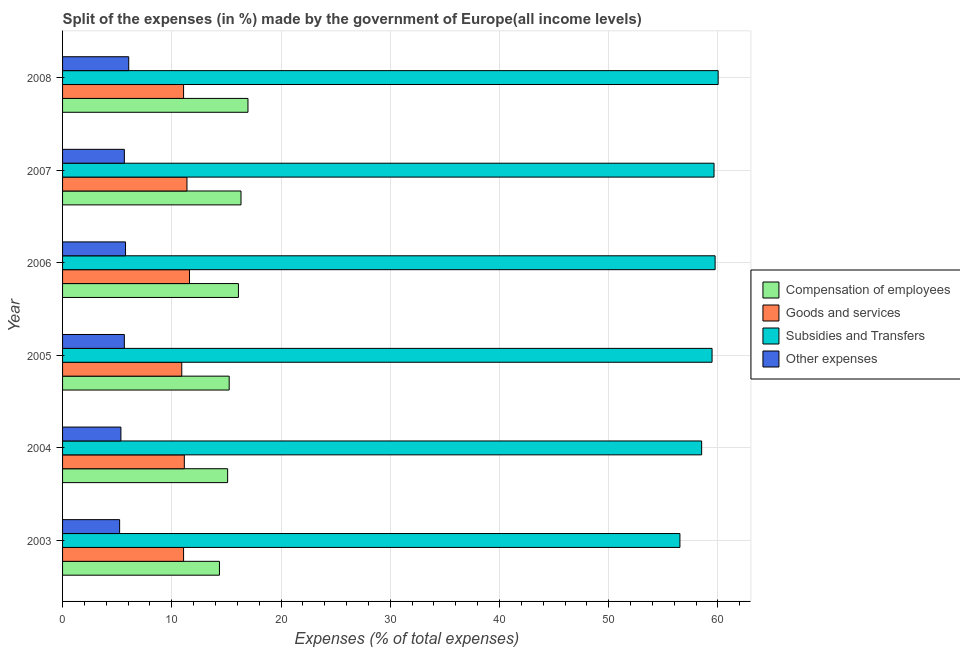How many groups of bars are there?
Keep it short and to the point. 6. How many bars are there on the 4th tick from the top?
Keep it short and to the point. 4. How many bars are there on the 6th tick from the bottom?
Ensure brevity in your answer.  4. In how many cases, is the number of bars for a given year not equal to the number of legend labels?
Make the answer very short. 0. What is the percentage of amount spent on goods and services in 2005?
Ensure brevity in your answer.  10.91. Across all years, what is the maximum percentage of amount spent on other expenses?
Your answer should be compact. 6.06. Across all years, what is the minimum percentage of amount spent on goods and services?
Provide a short and direct response. 10.91. In which year was the percentage of amount spent on goods and services minimum?
Your response must be concise. 2005. What is the total percentage of amount spent on compensation of employees in the graph?
Offer a terse response. 94.13. What is the difference between the percentage of amount spent on compensation of employees in 2007 and that in 2008?
Your response must be concise. -0.64. What is the difference between the percentage of amount spent on compensation of employees in 2007 and the percentage of amount spent on subsidies in 2008?
Provide a succinct answer. -43.68. What is the average percentage of amount spent on other expenses per year?
Give a very brief answer. 5.62. In the year 2007, what is the difference between the percentage of amount spent on compensation of employees and percentage of amount spent on other expenses?
Your answer should be compact. 10.68. What is the ratio of the percentage of amount spent on other expenses in 2003 to that in 2005?
Your response must be concise. 0.92. Is the difference between the percentage of amount spent on goods and services in 2005 and 2007 greater than the difference between the percentage of amount spent on compensation of employees in 2005 and 2007?
Offer a very short reply. Yes. What is the difference between the highest and the second highest percentage of amount spent on subsidies?
Your response must be concise. 0.28. What is the difference between the highest and the lowest percentage of amount spent on subsidies?
Offer a terse response. 3.5. In how many years, is the percentage of amount spent on other expenses greater than the average percentage of amount spent on other expenses taken over all years?
Your response must be concise. 4. Is the sum of the percentage of amount spent on compensation of employees in 2006 and 2007 greater than the maximum percentage of amount spent on subsidies across all years?
Provide a succinct answer. No. What does the 1st bar from the top in 2007 represents?
Your response must be concise. Other expenses. What does the 1st bar from the bottom in 2008 represents?
Your answer should be very brief. Compensation of employees. Is it the case that in every year, the sum of the percentage of amount spent on compensation of employees and percentage of amount spent on goods and services is greater than the percentage of amount spent on subsidies?
Your answer should be very brief. No. How many years are there in the graph?
Your response must be concise. 6. Where does the legend appear in the graph?
Offer a terse response. Center right. What is the title of the graph?
Keep it short and to the point. Split of the expenses (in %) made by the government of Europe(all income levels). What is the label or title of the X-axis?
Provide a succinct answer. Expenses (% of total expenses). What is the label or title of the Y-axis?
Provide a succinct answer. Year. What is the Expenses (% of total expenses) of Compensation of employees in 2003?
Give a very brief answer. 14.36. What is the Expenses (% of total expenses) in Goods and services in 2003?
Your answer should be very brief. 11.08. What is the Expenses (% of total expenses) of Subsidies and Transfers in 2003?
Your answer should be compact. 56.51. What is the Expenses (% of total expenses) in Other expenses in 2003?
Provide a succinct answer. 5.22. What is the Expenses (% of total expenses) in Compensation of employees in 2004?
Make the answer very short. 15.11. What is the Expenses (% of total expenses) of Goods and services in 2004?
Provide a short and direct response. 11.15. What is the Expenses (% of total expenses) in Subsidies and Transfers in 2004?
Keep it short and to the point. 58.5. What is the Expenses (% of total expenses) in Other expenses in 2004?
Your answer should be very brief. 5.34. What is the Expenses (% of total expenses) of Compensation of employees in 2005?
Make the answer very short. 15.25. What is the Expenses (% of total expenses) of Goods and services in 2005?
Provide a short and direct response. 10.91. What is the Expenses (% of total expenses) of Subsidies and Transfers in 2005?
Your response must be concise. 59.46. What is the Expenses (% of total expenses) in Other expenses in 2005?
Make the answer very short. 5.65. What is the Expenses (% of total expenses) of Compensation of employees in 2006?
Offer a terse response. 16.1. What is the Expenses (% of total expenses) of Goods and services in 2006?
Make the answer very short. 11.62. What is the Expenses (% of total expenses) of Subsidies and Transfers in 2006?
Ensure brevity in your answer.  59.74. What is the Expenses (% of total expenses) of Other expenses in 2006?
Offer a terse response. 5.76. What is the Expenses (% of total expenses) in Compensation of employees in 2007?
Make the answer very short. 16.34. What is the Expenses (% of total expenses) in Goods and services in 2007?
Give a very brief answer. 11.39. What is the Expenses (% of total expenses) in Subsidies and Transfers in 2007?
Make the answer very short. 59.64. What is the Expenses (% of total expenses) in Other expenses in 2007?
Provide a succinct answer. 5.66. What is the Expenses (% of total expenses) in Compensation of employees in 2008?
Keep it short and to the point. 16.97. What is the Expenses (% of total expenses) of Goods and services in 2008?
Offer a very short reply. 11.08. What is the Expenses (% of total expenses) in Subsidies and Transfers in 2008?
Provide a succinct answer. 60.01. What is the Expenses (% of total expenses) in Other expenses in 2008?
Offer a very short reply. 6.06. Across all years, what is the maximum Expenses (% of total expenses) in Compensation of employees?
Keep it short and to the point. 16.97. Across all years, what is the maximum Expenses (% of total expenses) in Goods and services?
Offer a very short reply. 11.62. Across all years, what is the maximum Expenses (% of total expenses) of Subsidies and Transfers?
Your answer should be compact. 60.01. Across all years, what is the maximum Expenses (% of total expenses) in Other expenses?
Provide a succinct answer. 6.06. Across all years, what is the minimum Expenses (% of total expenses) of Compensation of employees?
Offer a very short reply. 14.36. Across all years, what is the minimum Expenses (% of total expenses) of Goods and services?
Your answer should be compact. 10.91. Across all years, what is the minimum Expenses (% of total expenses) in Subsidies and Transfers?
Ensure brevity in your answer.  56.51. Across all years, what is the minimum Expenses (% of total expenses) of Other expenses?
Your answer should be very brief. 5.22. What is the total Expenses (% of total expenses) in Compensation of employees in the graph?
Your response must be concise. 94.13. What is the total Expenses (% of total expenses) of Goods and services in the graph?
Keep it short and to the point. 67.22. What is the total Expenses (% of total expenses) in Subsidies and Transfers in the graph?
Keep it short and to the point. 353.86. What is the total Expenses (% of total expenses) in Other expenses in the graph?
Ensure brevity in your answer.  33.7. What is the difference between the Expenses (% of total expenses) in Compensation of employees in 2003 and that in 2004?
Ensure brevity in your answer.  -0.75. What is the difference between the Expenses (% of total expenses) of Goods and services in 2003 and that in 2004?
Keep it short and to the point. -0.07. What is the difference between the Expenses (% of total expenses) of Subsidies and Transfers in 2003 and that in 2004?
Your response must be concise. -1.99. What is the difference between the Expenses (% of total expenses) of Other expenses in 2003 and that in 2004?
Provide a succinct answer. -0.12. What is the difference between the Expenses (% of total expenses) in Compensation of employees in 2003 and that in 2005?
Make the answer very short. -0.89. What is the difference between the Expenses (% of total expenses) in Goods and services in 2003 and that in 2005?
Provide a short and direct response. 0.17. What is the difference between the Expenses (% of total expenses) in Subsidies and Transfers in 2003 and that in 2005?
Offer a very short reply. -2.94. What is the difference between the Expenses (% of total expenses) in Other expenses in 2003 and that in 2005?
Your answer should be compact. -0.43. What is the difference between the Expenses (% of total expenses) in Compensation of employees in 2003 and that in 2006?
Provide a short and direct response. -1.74. What is the difference between the Expenses (% of total expenses) of Goods and services in 2003 and that in 2006?
Keep it short and to the point. -0.54. What is the difference between the Expenses (% of total expenses) of Subsidies and Transfers in 2003 and that in 2006?
Your answer should be compact. -3.22. What is the difference between the Expenses (% of total expenses) in Other expenses in 2003 and that in 2006?
Make the answer very short. -0.54. What is the difference between the Expenses (% of total expenses) of Compensation of employees in 2003 and that in 2007?
Make the answer very short. -1.97. What is the difference between the Expenses (% of total expenses) of Goods and services in 2003 and that in 2007?
Make the answer very short. -0.31. What is the difference between the Expenses (% of total expenses) of Subsidies and Transfers in 2003 and that in 2007?
Provide a short and direct response. -3.12. What is the difference between the Expenses (% of total expenses) in Other expenses in 2003 and that in 2007?
Your answer should be very brief. -0.43. What is the difference between the Expenses (% of total expenses) of Compensation of employees in 2003 and that in 2008?
Offer a very short reply. -2.61. What is the difference between the Expenses (% of total expenses) of Goods and services in 2003 and that in 2008?
Your response must be concise. -0. What is the difference between the Expenses (% of total expenses) of Other expenses in 2003 and that in 2008?
Give a very brief answer. -0.83. What is the difference between the Expenses (% of total expenses) of Compensation of employees in 2004 and that in 2005?
Offer a very short reply. -0.14. What is the difference between the Expenses (% of total expenses) of Goods and services in 2004 and that in 2005?
Provide a short and direct response. 0.24. What is the difference between the Expenses (% of total expenses) of Subsidies and Transfers in 2004 and that in 2005?
Your answer should be very brief. -0.95. What is the difference between the Expenses (% of total expenses) in Other expenses in 2004 and that in 2005?
Offer a very short reply. -0.31. What is the difference between the Expenses (% of total expenses) of Compensation of employees in 2004 and that in 2006?
Provide a short and direct response. -0.99. What is the difference between the Expenses (% of total expenses) of Goods and services in 2004 and that in 2006?
Your answer should be compact. -0.47. What is the difference between the Expenses (% of total expenses) in Subsidies and Transfers in 2004 and that in 2006?
Offer a terse response. -1.23. What is the difference between the Expenses (% of total expenses) in Other expenses in 2004 and that in 2006?
Offer a very short reply. -0.42. What is the difference between the Expenses (% of total expenses) in Compensation of employees in 2004 and that in 2007?
Provide a succinct answer. -1.22. What is the difference between the Expenses (% of total expenses) in Goods and services in 2004 and that in 2007?
Your response must be concise. -0.24. What is the difference between the Expenses (% of total expenses) of Subsidies and Transfers in 2004 and that in 2007?
Your answer should be very brief. -1.13. What is the difference between the Expenses (% of total expenses) of Other expenses in 2004 and that in 2007?
Provide a short and direct response. -0.32. What is the difference between the Expenses (% of total expenses) of Compensation of employees in 2004 and that in 2008?
Keep it short and to the point. -1.86. What is the difference between the Expenses (% of total expenses) in Goods and services in 2004 and that in 2008?
Keep it short and to the point. 0.07. What is the difference between the Expenses (% of total expenses) in Subsidies and Transfers in 2004 and that in 2008?
Your answer should be compact. -1.51. What is the difference between the Expenses (% of total expenses) of Other expenses in 2004 and that in 2008?
Your response must be concise. -0.71. What is the difference between the Expenses (% of total expenses) of Compensation of employees in 2005 and that in 2006?
Offer a terse response. -0.85. What is the difference between the Expenses (% of total expenses) in Goods and services in 2005 and that in 2006?
Give a very brief answer. -0.71. What is the difference between the Expenses (% of total expenses) in Subsidies and Transfers in 2005 and that in 2006?
Make the answer very short. -0.28. What is the difference between the Expenses (% of total expenses) in Other expenses in 2005 and that in 2006?
Your answer should be compact. -0.11. What is the difference between the Expenses (% of total expenses) in Compensation of employees in 2005 and that in 2007?
Give a very brief answer. -1.08. What is the difference between the Expenses (% of total expenses) of Goods and services in 2005 and that in 2007?
Make the answer very short. -0.48. What is the difference between the Expenses (% of total expenses) in Subsidies and Transfers in 2005 and that in 2007?
Provide a short and direct response. -0.18. What is the difference between the Expenses (% of total expenses) of Other expenses in 2005 and that in 2007?
Offer a terse response. -0. What is the difference between the Expenses (% of total expenses) of Compensation of employees in 2005 and that in 2008?
Provide a short and direct response. -1.72. What is the difference between the Expenses (% of total expenses) in Goods and services in 2005 and that in 2008?
Give a very brief answer. -0.17. What is the difference between the Expenses (% of total expenses) in Subsidies and Transfers in 2005 and that in 2008?
Ensure brevity in your answer.  -0.56. What is the difference between the Expenses (% of total expenses) in Other expenses in 2005 and that in 2008?
Ensure brevity in your answer.  -0.4. What is the difference between the Expenses (% of total expenses) of Compensation of employees in 2006 and that in 2007?
Offer a very short reply. -0.24. What is the difference between the Expenses (% of total expenses) in Goods and services in 2006 and that in 2007?
Ensure brevity in your answer.  0.23. What is the difference between the Expenses (% of total expenses) of Subsidies and Transfers in 2006 and that in 2007?
Offer a very short reply. 0.1. What is the difference between the Expenses (% of total expenses) of Other expenses in 2006 and that in 2007?
Offer a terse response. 0.11. What is the difference between the Expenses (% of total expenses) in Compensation of employees in 2006 and that in 2008?
Ensure brevity in your answer.  -0.87. What is the difference between the Expenses (% of total expenses) in Goods and services in 2006 and that in 2008?
Your answer should be compact. 0.54. What is the difference between the Expenses (% of total expenses) of Subsidies and Transfers in 2006 and that in 2008?
Provide a succinct answer. -0.28. What is the difference between the Expenses (% of total expenses) of Other expenses in 2006 and that in 2008?
Give a very brief answer. -0.29. What is the difference between the Expenses (% of total expenses) in Compensation of employees in 2007 and that in 2008?
Your response must be concise. -0.64. What is the difference between the Expenses (% of total expenses) in Goods and services in 2007 and that in 2008?
Provide a short and direct response. 0.31. What is the difference between the Expenses (% of total expenses) of Subsidies and Transfers in 2007 and that in 2008?
Your answer should be compact. -0.38. What is the difference between the Expenses (% of total expenses) in Other expenses in 2007 and that in 2008?
Ensure brevity in your answer.  -0.4. What is the difference between the Expenses (% of total expenses) of Compensation of employees in 2003 and the Expenses (% of total expenses) of Goods and services in 2004?
Your answer should be compact. 3.22. What is the difference between the Expenses (% of total expenses) of Compensation of employees in 2003 and the Expenses (% of total expenses) of Subsidies and Transfers in 2004?
Provide a short and direct response. -44.14. What is the difference between the Expenses (% of total expenses) of Compensation of employees in 2003 and the Expenses (% of total expenses) of Other expenses in 2004?
Offer a terse response. 9.02. What is the difference between the Expenses (% of total expenses) in Goods and services in 2003 and the Expenses (% of total expenses) in Subsidies and Transfers in 2004?
Your response must be concise. -47.43. What is the difference between the Expenses (% of total expenses) of Goods and services in 2003 and the Expenses (% of total expenses) of Other expenses in 2004?
Offer a terse response. 5.74. What is the difference between the Expenses (% of total expenses) of Subsidies and Transfers in 2003 and the Expenses (% of total expenses) of Other expenses in 2004?
Give a very brief answer. 51.17. What is the difference between the Expenses (% of total expenses) of Compensation of employees in 2003 and the Expenses (% of total expenses) of Goods and services in 2005?
Ensure brevity in your answer.  3.45. What is the difference between the Expenses (% of total expenses) in Compensation of employees in 2003 and the Expenses (% of total expenses) in Subsidies and Transfers in 2005?
Your answer should be very brief. -45.1. What is the difference between the Expenses (% of total expenses) in Compensation of employees in 2003 and the Expenses (% of total expenses) in Other expenses in 2005?
Make the answer very short. 8.71. What is the difference between the Expenses (% of total expenses) in Goods and services in 2003 and the Expenses (% of total expenses) in Subsidies and Transfers in 2005?
Offer a very short reply. -48.38. What is the difference between the Expenses (% of total expenses) in Goods and services in 2003 and the Expenses (% of total expenses) in Other expenses in 2005?
Make the answer very short. 5.42. What is the difference between the Expenses (% of total expenses) in Subsidies and Transfers in 2003 and the Expenses (% of total expenses) in Other expenses in 2005?
Offer a terse response. 50.86. What is the difference between the Expenses (% of total expenses) of Compensation of employees in 2003 and the Expenses (% of total expenses) of Goods and services in 2006?
Offer a very short reply. 2.74. What is the difference between the Expenses (% of total expenses) of Compensation of employees in 2003 and the Expenses (% of total expenses) of Subsidies and Transfers in 2006?
Give a very brief answer. -45.37. What is the difference between the Expenses (% of total expenses) in Compensation of employees in 2003 and the Expenses (% of total expenses) in Other expenses in 2006?
Ensure brevity in your answer.  8.6. What is the difference between the Expenses (% of total expenses) in Goods and services in 2003 and the Expenses (% of total expenses) in Subsidies and Transfers in 2006?
Ensure brevity in your answer.  -48.66. What is the difference between the Expenses (% of total expenses) of Goods and services in 2003 and the Expenses (% of total expenses) of Other expenses in 2006?
Keep it short and to the point. 5.31. What is the difference between the Expenses (% of total expenses) in Subsidies and Transfers in 2003 and the Expenses (% of total expenses) in Other expenses in 2006?
Your answer should be compact. 50.75. What is the difference between the Expenses (% of total expenses) of Compensation of employees in 2003 and the Expenses (% of total expenses) of Goods and services in 2007?
Your response must be concise. 2.97. What is the difference between the Expenses (% of total expenses) of Compensation of employees in 2003 and the Expenses (% of total expenses) of Subsidies and Transfers in 2007?
Your answer should be compact. -45.28. What is the difference between the Expenses (% of total expenses) in Compensation of employees in 2003 and the Expenses (% of total expenses) in Other expenses in 2007?
Your answer should be very brief. 8.7. What is the difference between the Expenses (% of total expenses) in Goods and services in 2003 and the Expenses (% of total expenses) in Subsidies and Transfers in 2007?
Provide a succinct answer. -48.56. What is the difference between the Expenses (% of total expenses) of Goods and services in 2003 and the Expenses (% of total expenses) of Other expenses in 2007?
Ensure brevity in your answer.  5.42. What is the difference between the Expenses (% of total expenses) in Subsidies and Transfers in 2003 and the Expenses (% of total expenses) in Other expenses in 2007?
Give a very brief answer. 50.86. What is the difference between the Expenses (% of total expenses) in Compensation of employees in 2003 and the Expenses (% of total expenses) in Goods and services in 2008?
Provide a short and direct response. 3.28. What is the difference between the Expenses (% of total expenses) in Compensation of employees in 2003 and the Expenses (% of total expenses) in Subsidies and Transfers in 2008?
Provide a short and direct response. -45.65. What is the difference between the Expenses (% of total expenses) of Compensation of employees in 2003 and the Expenses (% of total expenses) of Other expenses in 2008?
Your answer should be very brief. 8.31. What is the difference between the Expenses (% of total expenses) of Goods and services in 2003 and the Expenses (% of total expenses) of Subsidies and Transfers in 2008?
Make the answer very short. -48.94. What is the difference between the Expenses (% of total expenses) in Goods and services in 2003 and the Expenses (% of total expenses) in Other expenses in 2008?
Make the answer very short. 5.02. What is the difference between the Expenses (% of total expenses) of Subsidies and Transfers in 2003 and the Expenses (% of total expenses) of Other expenses in 2008?
Give a very brief answer. 50.46. What is the difference between the Expenses (% of total expenses) of Compensation of employees in 2004 and the Expenses (% of total expenses) of Goods and services in 2005?
Offer a terse response. 4.2. What is the difference between the Expenses (% of total expenses) in Compensation of employees in 2004 and the Expenses (% of total expenses) in Subsidies and Transfers in 2005?
Offer a terse response. -44.35. What is the difference between the Expenses (% of total expenses) in Compensation of employees in 2004 and the Expenses (% of total expenses) in Other expenses in 2005?
Make the answer very short. 9.46. What is the difference between the Expenses (% of total expenses) in Goods and services in 2004 and the Expenses (% of total expenses) in Subsidies and Transfers in 2005?
Provide a succinct answer. -48.31. What is the difference between the Expenses (% of total expenses) of Goods and services in 2004 and the Expenses (% of total expenses) of Other expenses in 2005?
Make the answer very short. 5.49. What is the difference between the Expenses (% of total expenses) of Subsidies and Transfers in 2004 and the Expenses (% of total expenses) of Other expenses in 2005?
Your answer should be very brief. 52.85. What is the difference between the Expenses (% of total expenses) in Compensation of employees in 2004 and the Expenses (% of total expenses) in Goods and services in 2006?
Keep it short and to the point. 3.49. What is the difference between the Expenses (% of total expenses) of Compensation of employees in 2004 and the Expenses (% of total expenses) of Subsidies and Transfers in 2006?
Your response must be concise. -44.62. What is the difference between the Expenses (% of total expenses) of Compensation of employees in 2004 and the Expenses (% of total expenses) of Other expenses in 2006?
Offer a very short reply. 9.35. What is the difference between the Expenses (% of total expenses) in Goods and services in 2004 and the Expenses (% of total expenses) in Subsidies and Transfers in 2006?
Your answer should be compact. -48.59. What is the difference between the Expenses (% of total expenses) in Goods and services in 2004 and the Expenses (% of total expenses) in Other expenses in 2006?
Your answer should be very brief. 5.38. What is the difference between the Expenses (% of total expenses) of Subsidies and Transfers in 2004 and the Expenses (% of total expenses) of Other expenses in 2006?
Ensure brevity in your answer.  52.74. What is the difference between the Expenses (% of total expenses) in Compensation of employees in 2004 and the Expenses (% of total expenses) in Goods and services in 2007?
Provide a succinct answer. 3.72. What is the difference between the Expenses (% of total expenses) of Compensation of employees in 2004 and the Expenses (% of total expenses) of Subsidies and Transfers in 2007?
Provide a succinct answer. -44.53. What is the difference between the Expenses (% of total expenses) in Compensation of employees in 2004 and the Expenses (% of total expenses) in Other expenses in 2007?
Make the answer very short. 9.45. What is the difference between the Expenses (% of total expenses) of Goods and services in 2004 and the Expenses (% of total expenses) of Subsidies and Transfers in 2007?
Make the answer very short. -48.49. What is the difference between the Expenses (% of total expenses) in Goods and services in 2004 and the Expenses (% of total expenses) in Other expenses in 2007?
Ensure brevity in your answer.  5.49. What is the difference between the Expenses (% of total expenses) in Subsidies and Transfers in 2004 and the Expenses (% of total expenses) in Other expenses in 2007?
Your answer should be very brief. 52.85. What is the difference between the Expenses (% of total expenses) of Compensation of employees in 2004 and the Expenses (% of total expenses) of Goods and services in 2008?
Give a very brief answer. 4.03. What is the difference between the Expenses (% of total expenses) of Compensation of employees in 2004 and the Expenses (% of total expenses) of Subsidies and Transfers in 2008?
Your answer should be very brief. -44.9. What is the difference between the Expenses (% of total expenses) of Compensation of employees in 2004 and the Expenses (% of total expenses) of Other expenses in 2008?
Offer a very short reply. 9.06. What is the difference between the Expenses (% of total expenses) in Goods and services in 2004 and the Expenses (% of total expenses) in Subsidies and Transfers in 2008?
Keep it short and to the point. -48.87. What is the difference between the Expenses (% of total expenses) of Goods and services in 2004 and the Expenses (% of total expenses) of Other expenses in 2008?
Your answer should be very brief. 5.09. What is the difference between the Expenses (% of total expenses) in Subsidies and Transfers in 2004 and the Expenses (% of total expenses) in Other expenses in 2008?
Your answer should be very brief. 52.45. What is the difference between the Expenses (% of total expenses) in Compensation of employees in 2005 and the Expenses (% of total expenses) in Goods and services in 2006?
Your answer should be very brief. 3.63. What is the difference between the Expenses (% of total expenses) of Compensation of employees in 2005 and the Expenses (% of total expenses) of Subsidies and Transfers in 2006?
Your response must be concise. -44.48. What is the difference between the Expenses (% of total expenses) of Compensation of employees in 2005 and the Expenses (% of total expenses) of Other expenses in 2006?
Your answer should be compact. 9.49. What is the difference between the Expenses (% of total expenses) in Goods and services in 2005 and the Expenses (% of total expenses) in Subsidies and Transfers in 2006?
Your response must be concise. -48.82. What is the difference between the Expenses (% of total expenses) of Goods and services in 2005 and the Expenses (% of total expenses) of Other expenses in 2006?
Your response must be concise. 5.15. What is the difference between the Expenses (% of total expenses) of Subsidies and Transfers in 2005 and the Expenses (% of total expenses) of Other expenses in 2006?
Provide a short and direct response. 53.69. What is the difference between the Expenses (% of total expenses) of Compensation of employees in 2005 and the Expenses (% of total expenses) of Goods and services in 2007?
Keep it short and to the point. 3.87. What is the difference between the Expenses (% of total expenses) of Compensation of employees in 2005 and the Expenses (% of total expenses) of Subsidies and Transfers in 2007?
Offer a terse response. -44.38. What is the difference between the Expenses (% of total expenses) in Compensation of employees in 2005 and the Expenses (% of total expenses) in Other expenses in 2007?
Offer a terse response. 9.6. What is the difference between the Expenses (% of total expenses) in Goods and services in 2005 and the Expenses (% of total expenses) in Subsidies and Transfers in 2007?
Keep it short and to the point. -48.73. What is the difference between the Expenses (% of total expenses) in Goods and services in 2005 and the Expenses (% of total expenses) in Other expenses in 2007?
Your answer should be very brief. 5.25. What is the difference between the Expenses (% of total expenses) in Subsidies and Transfers in 2005 and the Expenses (% of total expenses) in Other expenses in 2007?
Your answer should be very brief. 53.8. What is the difference between the Expenses (% of total expenses) in Compensation of employees in 2005 and the Expenses (% of total expenses) in Goods and services in 2008?
Ensure brevity in your answer.  4.18. What is the difference between the Expenses (% of total expenses) of Compensation of employees in 2005 and the Expenses (% of total expenses) of Subsidies and Transfers in 2008?
Your answer should be compact. -44.76. What is the difference between the Expenses (% of total expenses) in Compensation of employees in 2005 and the Expenses (% of total expenses) in Other expenses in 2008?
Your answer should be very brief. 9.2. What is the difference between the Expenses (% of total expenses) in Goods and services in 2005 and the Expenses (% of total expenses) in Subsidies and Transfers in 2008?
Give a very brief answer. -49.1. What is the difference between the Expenses (% of total expenses) in Goods and services in 2005 and the Expenses (% of total expenses) in Other expenses in 2008?
Keep it short and to the point. 4.86. What is the difference between the Expenses (% of total expenses) in Subsidies and Transfers in 2005 and the Expenses (% of total expenses) in Other expenses in 2008?
Your response must be concise. 53.4. What is the difference between the Expenses (% of total expenses) of Compensation of employees in 2006 and the Expenses (% of total expenses) of Goods and services in 2007?
Offer a very short reply. 4.71. What is the difference between the Expenses (% of total expenses) in Compensation of employees in 2006 and the Expenses (% of total expenses) in Subsidies and Transfers in 2007?
Your answer should be very brief. -43.54. What is the difference between the Expenses (% of total expenses) of Compensation of employees in 2006 and the Expenses (% of total expenses) of Other expenses in 2007?
Provide a succinct answer. 10.44. What is the difference between the Expenses (% of total expenses) of Goods and services in 2006 and the Expenses (% of total expenses) of Subsidies and Transfers in 2007?
Keep it short and to the point. -48.02. What is the difference between the Expenses (% of total expenses) in Goods and services in 2006 and the Expenses (% of total expenses) in Other expenses in 2007?
Offer a very short reply. 5.96. What is the difference between the Expenses (% of total expenses) of Subsidies and Transfers in 2006 and the Expenses (% of total expenses) of Other expenses in 2007?
Keep it short and to the point. 54.08. What is the difference between the Expenses (% of total expenses) of Compensation of employees in 2006 and the Expenses (% of total expenses) of Goods and services in 2008?
Offer a terse response. 5.02. What is the difference between the Expenses (% of total expenses) of Compensation of employees in 2006 and the Expenses (% of total expenses) of Subsidies and Transfers in 2008?
Offer a very short reply. -43.91. What is the difference between the Expenses (% of total expenses) of Compensation of employees in 2006 and the Expenses (% of total expenses) of Other expenses in 2008?
Provide a short and direct response. 10.04. What is the difference between the Expenses (% of total expenses) in Goods and services in 2006 and the Expenses (% of total expenses) in Subsidies and Transfers in 2008?
Offer a terse response. -48.4. What is the difference between the Expenses (% of total expenses) in Goods and services in 2006 and the Expenses (% of total expenses) in Other expenses in 2008?
Ensure brevity in your answer.  5.56. What is the difference between the Expenses (% of total expenses) of Subsidies and Transfers in 2006 and the Expenses (% of total expenses) of Other expenses in 2008?
Your answer should be very brief. 53.68. What is the difference between the Expenses (% of total expenses) of Compensation of employees in 2007 and the Expenses (% of total expenses) of Goods and services in 2008?
Provide a short and direct response. 5.26. What is the difference between the Expenses (% of total expenses) of Compensation of employees in 2007 and the Expenses (% of total expenses) of Subsidies and Transfers in 2008?
Provide a succinct answer. -43.68. What is the difference between the Expenses (% of total expenses) in Compensation of employees in 2007 and the Expenses (% of total expenses) in Other expenses in 2008?
Your response must be concise. 10.28. What is the difference between the Expenses (% of total expenses) in Goods and services in 2007 and the Expenses (% of total expenses) in Subsidies and Transfers in 2008?
Your answer should be very brief. -48.63. What is the difference between the Expenses (% of total expenses) of Goods and services in 2007 and the Expenses (% of total expenses) of Other expenses in 2008?
Your answer should be very brief. 5.33. What is the difference between the Expenses (% of total expenses) in Subsidies and Transfers in 2007 and the Expenses (% of total expenses) in Other expenses in 2008?
Give a very brief answer. 53.58. What is the average Expenses (% of total expenses) in Compensation of employees per year?
Offer a very short reply. 15.69. What is the average Expenses (% of total expenses) in Goods and services per year?
Give a very brief answer. 11.2. What is the average Expenses (% of total expenses) of Subsidies and Transfers per year?
Give a very brief answer. 58.98. What is the average Expenses (% of total expenses) of Other expenses per year?
Your response must be concise. 5.62. In the year 2003, what is the difference between the Expenses (% of total expenses) of Compensation of employees and Expenses (% of total expenses) of Goods and services?
Offer a very short reply. 3.28. In the year 2003, what is the difference between the Expenses (% of total expenses) of Compensation of employees and Expenses (% of total expenses) of Subsidies and Transfers?
Make the answer very short. -42.15. In the year 2003, what is the difference between the Expenses (% of total expenses) of Compensation of employees and Expenses (% of total expenses) of Other expenses?
Provide a short and direct response. 9.14. In the year 2003, what is the difference between the Expenses (% of total expenses) in Goods and services and Expenses (% of total expenses) in Subsidies and Transfers?
Your response must be concise. -45.44. In the year 2003, what is the difference between the Expenses (% of total expenses) of Goods and services and Expenses (% of total expenses) of Other expenses?
Your answer should be very brief. 5.85. In the year 2003, what is the difference between the Expenses (% of total expenses) of Subsidies and Transfers and Expenses (% of total expenses) of Other expenses?
Provide a short and direct response. 51.29. In the year 2004, what is the difference between the Expenses (% of total expenses) of Compensation of employees and Expenses (% of total expenses) of Goods and services?
Your response must be concise. 3.96. In the year 2004, what is the difference between the Expenses (% of total expenses) in Compensation of employees and Expenses (% of total expenses) in Subsidies and Transfers?
Offer a terse response. -43.39. In the year 2004, what is the difference between the Expenses (% of total expenses) of Compensation of employees and Expenses (% of total expenses) of Other expenses?
Your answer should be very brief. 9.77. In the year 2004, what is the difference between the Expenses (% of total expenses) of Goods and services and Expenses (% of total expenses) of Subsidies and Transfers?
Keep it short and to the point. -47.36. In the year 2004, what is the difference between the Expenses (% of total expenses) of Goods and services and Expenses (% of total expenses) of Other expenses?
Provide a succinct answer. 5.81. In the year 2004, what is the difference between the Expenses (% of total expenses) of Subsidies and Transfers and Expenses (% of total expenses) of Other expenses?
Your response must be concise. 53.16. In the year 2005, what is the difference between the Expenses (% of total expenses) in Compensation of employees and Expenses (% of total expenses) in Goods and services?
Your answer should be very brief. 4.34. In the year 2005, what is the difference between the Expenses (% of total expenses) in Compensation of employees and Expenses (% of total expenses) in Subsidies and Transfers?
Offer a very short reply. -44.2. In the year 2005, what is the difference between the Expenses (% of total expenses) of Compensation of employees and Expenses (% of total expenses) of Other expenses?
Your answer should be very brief. 9.6. In the year 2005, what is the difference between the Expenses (% of total expenses) of Goods and services and Expenses (% of total expenses) of Subsidies and Transfers?
Your answer should be compact. -48.55. In the year 2005, what is the difference between the Expenses (% of total expenses) in Goods and services and Expenses (% of total expenses) in Other expenses?
Your answer should be compact. 5.26. In the year 2005, what is the difference between the Expenses (% of total expenses) of Subsidies and Transfers and Expenses (% of total expenses) of Other expenses?
Provide a succinct answer. 53.8. In the year 2006, what is the difference between the Expenses (% of total expenses) in Compensation of employees and Expenses (% of total expenses) in Goods and services?
Give a very brief answer. 4.48. In the year 2006, what is the difference between the Expenses (% of total expenses) in Compensation of employees and Expenses (% of total expenses) in Subsidies and Transfers?
Offer a very short reply. -43.64. In the year 2006, what is the difference between the Expenses (% of total expenses) in Compensation of employees and Expenses (% of total expenses) in Other expenses?
Your response must be concise. 10.34. In the year 2006, what is the difference between the Expenses (% of total expenses) of Goods and services and Expenses (% of total expenses) of Subsidies and Transfers?
Offer a terse response. -48.12. In the year 2006, what is the difference between the Expenses (% of total expenses) in Goods and services and Expenses (% of total expenses) in Other expenses?
Give a very brief answer. 5.85. In the year 2006, what is the difference between the Expenses (% of total expenses) of Subsidies and Transfers and Expenses (% of total expenses) of Other expenses?
Offer a very short reply. 53.97. In the year 2007, what is the difference between the Expenses (% of total expenses) in Compensation of employees and Expenses (% of total expenses) in Goods and services?
Your answer should be very brief. 4.95. In the year 2007, what is the difference between the Expenses (% of total expenses) of Compensation of employees and Expenses (% of total expenses) of Subsidies and Transfers?
Your answer should be very brief. -43.3. In the year 2007, what is the difference between the Expenses (% of total expenses) of Compensation of employees and Expenses (% of total expenses) of Other expenses?
Your answer should be very brief. 10.68. In the year 2007, what is the difference between the Expenses (% of total expenses) of Goods and services and Expenses (% of total expenses) of Subsidies and Transfers?
Your response must be concise. -48.25. In the year 2007, what is the difference between the Expenses (% of total expenses) in Goods and services and Expenses (% of total expenses) in Other expenses?
Provide a short and direct response. 5.73. In the year 2007, what is the difference between the Expenses (% of total expenses) of Subsidies and Transfers and Expenses (% of total expenses) of Other expenses?
Your response must be concise. 53.98. In the year 2008, what is the difference between the Expenses (% of total expenses) in Compensation of employees and Expenses (% of total expenses) in Goods and services?
Your response must be concise. 5.89. In the year 2008, what is the difference between the Expenses (% of total expenses) in Compensation of employees and Expenses (% of total expenses) in Subsidies and Transfers?
Make the answer very short. -43.04. In the year 2008, what is the difference between the Expenses (% of total expenses) in Compensation of employees and Expenses (% of total expenses) in Other expenses?
Give a very brief answer. 10.92. In the year 2008, what is the difference between the Expenses (% of total expenses) of Goods and services and Expenses (% of total expenses) of Subsidies and Transfers?
Give a very brief answer. -48.94. In the year 2008, what is the difference between the Expenses (% of total expenses) of Goods and services and Expenses (% of total expenses) of Other expenses?
Provide a short and direct response. 5.02. In the year 2008, what is the difference between the Expenses (% of total expenses) of Subsidies and Transfers and Expenses (% of total expenses) of Other expenses?
Keep it short and to the point. 53.96. What is the ratio of the Expenses (% of total expenses) of Compensation of employees in 2003 to that in 2004?
Your response must be concise. 0.95. What is the ratio of the Expenses (% of total expenses) in Goods and services in 2003 to that in 2004?
Give a very brief answer. 0.99. What is the ratio of the Expenses (% of total expenses) in Subsidies and Transfers in 2003 to that in 2004?
Ensure brevity in your answer.  0.97. What is the ratio of the Expenses (% of total expenses) of Other expenses in 2003 to that in 2004?
Offer a terse response. 0.98. What is the ratio of the Expenses (% of total expenses) of Compensation of employees in 2003 to that in 2005?
Ensure brevity in your answer.  0.94. What is the ratio of the Expenses (% of total expenses) in Goods and services in 2003 to that in 2005?
Your answer should be compact. 1.02. What is the ratio of the Expenses (% of total expenses) of Subsidies and Transfers in 2003 to that in 2005?
Offer a terse response. 0.95. What is the ratio of the Expenses (% of total expenses) of Other expenses in 2003 to that in 2005?
Provide a short and direct response. 0.92. What is the ratio of the Expenses (% of total expenses) in Compensation of employees in 2003 to that in 2006?
Offer a very short reply. 0.89. What is the ratio of the Expenses (% of total expenses) in Goods and services in 2003 to that in 2006?
Make the answer very short. 0.95. What is the ratio of the Expenses (% of total expenses) of Subsidies and Transfers in 2003 to that in 2006?
Ensure brevity in your answer.  0.95. What is the ratio of the Expenses (% of total expenses) of Other expenses in 2003 to that in 2006?
Your answer should be very brief. 0.91. What is the ratio of the Expenses (% of total expenses) in Compensation of employees in 2003 to that in 2007?
Offer a very short reply. 0.88. What is the ratio of the Expenses (% of total expenses) in Goods and services in 2003 to that in 2007?
Make the answer very short. 0.97. What is the ratio of the Expenses (% of total expenses) of Subsidies and Transfers in 2003 to that in 2007?
Give a very brief answer. 0.95. What is the ratio of the Expenses (% of total expenses) of Other expenses in 2003 to that in 2007?
Your response must be concise. 0.92. What is the ratio of the Expenses (% of total expenses) of Compensation of employees in 2003 to that in 2008?
Your response must be concise. 0.85. What is the ratio of the Expenses (% of total expenses) in Subsidies and Transfers in 2003 to that in 2008?
Offer a very short reply. 0.94. What is the ratio of the Expenses (% of total expenses) in Other expenses in 2003 to that in 2008?
Provide a short and direct response. 0.86. What is the ratio of the Expenses (% of total expenses) in Compensation of employees in 2004 to that in 2005?
Offer a very short reply. 0.99. What is the ratio of the Expenses (% of total expenses) in Goods and services in 2004 to that in 2005?
Give a very brief answer. 1.02. What is the ratio of the Expenses (% of total expenses) in Subsidies and Transfers in 2004 to that in 2005?
Provide a short and direct response. 0.98. What is the ratio of the Expenses (% of total expenses) of Other expenses in 2004 to that in 2005?
Your answer should be compact. 0.94. What is the ratio of the Expenses (% of total expenses) of Compensation of employees in 2004 to that in 2006?
Provide a succinct answer. 0.94. What is the ratio of the Expenses (% of total expenses) in Goods and services in 2004 to that in 2006?
Your answer should be compact. 0.96. What is the ratio of the Expenses (% of total expenses) of Subsidies and Transfers in 2004 to that in 2006?
Offer a terse response. 0.98. What is the ratio of the Expenses (% of total expenses) in Other expenses in 2004 to that in 2006?
Ensure brevity in your answer.  0.93. What is the ratio of the Expenses (% of total expenses) in Compensation of employees in 2004 to that in 2007?
Give a very brief answer. 0.93. What is the ratio of the Expenses (% of total expenses) in Goods and services in 2004 to that in 2007?
Offer a terse response. 0.98. What is the ratio of the Expenses (% of total expenses) of Subsidies and Transfers in 2004 to that in 2007?
Give a very brief answer. 0.98. What is the ratio of the Expenses (% of total expenses) of Other expenses in 2004 to that in 2007?
Make the answer very short. 0.94. What is the ratio of the Expenses (% of total expenses) in Compensation of employees in 2004 to that in 2008?
Keep it short and to the point. 0.89. What is the ratio of the Expenses (% of total expenses) in Goods and services in 2004 to that in 2008?
Make the answer very short. 1.01. What is the ratio of the Expenses (% of total expenses) in Subsidies and Transfers in 2004 to that in 2008?
Make the answer very short. 0.97. What is the ratio of the Expenses (% of total expenses) in Other expenses in 2004 to that in 2008?
Provide a succinct answer. 0.88. What is the ratio of the Expenses (% of total expenses) in Goods and services in 2005 to that in 2006?
Keep it short and to the point. 0.94. What is the ratio of the Expenses (% of total expenses) of Subsidies and Transfers in 2005 to that in 2006?
Your answer should be very brief. 1. What is the ratio of the Expenses (% of total expenses) in Compensation of employees in 2005 to that in 2007?
Offer a very short reply. 0.93. What is the ratio of the Expenses (% of total expenses) of Goods and services in 2005 to that in 2007?
Offer a very short reply. 0.96. What is the ratio of the Expenses (% of total expenses) of Other expenses in 2005 to that in 2007?
Your answer should be very brief. 1. What is the ratio of the Expenses (% of total expenses) in Compensation of employees in 2005 to that in 2008?
Your answer should be compact. 0.9. What is the ratio of the Expenses (% of total expenses) of Goods and services in 2005 to that in 2008?
Keep it short and to the point. 0.98. What is the ratio of the Expenses (% of total expenses) in Subsidies and Transfers in 2005 to that in 2008?
Your answer should be compact. 0.99. What is the ratio of the Expenses (% of total expenses) of Other expenses in 2005 to that in 2008?
Offer a very short reply. 0.93. What is the ratio of the Expenses (% of total expenses) of Compensation of employees in 2006 to that in 2007?
Keep it short and to the point. 0.99. What is the ratio of the Expenses (% of total expenses) of Goods and services in 2006 to that in 2007?
Provide a succinct answer. 1.02. What is the ratio of the Expenses (% of total expenses) in Subsidies and Transfers in 2006 to that in 2007?
Offer a terse response. 1. What is the ratio of the Expenses (% of total expenses) of Other expenses in 2006 to that in 2007?
Offer a very short reply. 1.02. What is the ratio of the Expenses (% of total expenses) of Compensation of employees in 2006 to that in 2008?
Your response must be concise. 0.95. What is the ratio of the Expenses (% of total expenses) of Goods and services in 2006 to that in 2008?
Your response must be concise. 1.05. What is the ratio of the Expenses (% of total expenses) of Subsidies and Transfers in 2006 to that in 2008?
Offer a terse response. 1. What is the ratio of the Expenses (% of total expenses) in Other expenses in 2006 to that in 2008?
Offer a very short reply. 0.95. What is the ratio of the Expenses (% of total expenses) of Compensation of employees in 2007 to that in 2008?
Your answer should be compact. 0.96. What is the ratio of the Expenses (% of total expenses) in Goods and services in 2007 to that in 2008?
Your answer should be very brief. 1.03. What is the ratio of the Expenses (% of total expenses) in Other expenses in 2007 to that in 2008?
Your response must be concise. 0.93. What is the difference between the highest and the second highest Expenses (% of total expenses) of Compensation of employees?
Your answer should be compact. 0.64. What is the difference between the highest and the second highest Expenses (% of total expenses) in Goods and services?
Offer a very short reply. 0.23. What is the difference between the highest and the second highest Expenses (% of total expenses) of Subsidies and Transfers?
Offer a very short reply. 0.28. What is the difference between the highest and the second highest Expenses (% of total expenses) of Other expenses?
Ensure brevity in your answer.  0.29. What is the difference between the highest and the lowest Expenses (% of total expenses) in Compensation of employees?
Ensure brevity in your answer.  2.61. What is the difference between the highest and the lowest Expenses (% of total expenses) of Goods and services?
Your answer should be compact. 0.71. What is the difference between the highest and the lowest Expenses (% of total expenses) in Subsidies and Transfers?
Offer a very short reply. 3.5. What is the difference between the highest and the lowest Expenses (% of total expenses) in Other expenses?
Ensure brevity in your answer.  0.83. 